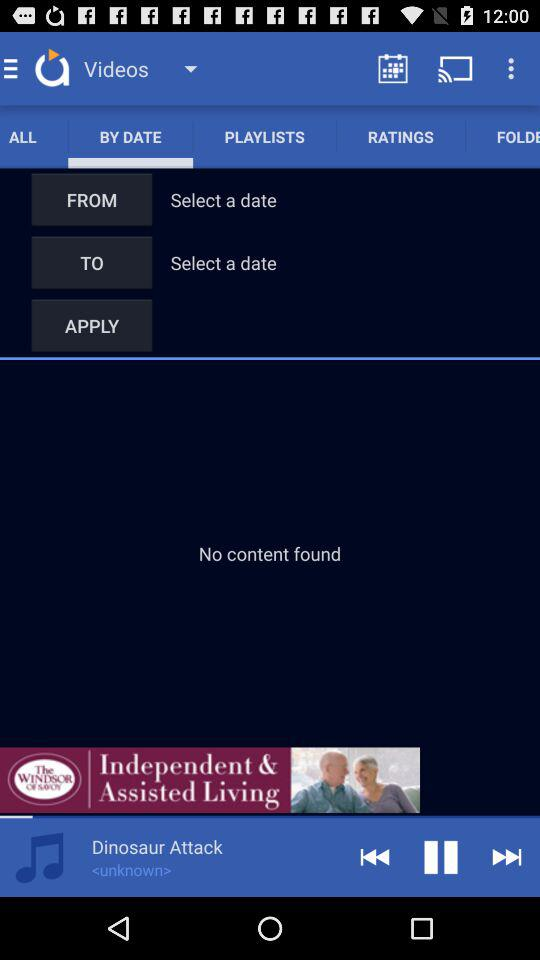Which audio is currently playing? The currently playing audio is "Dinosaur Attack". 